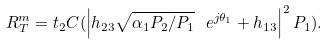Convert formula to latex. <formula><loc_0><loc_0><loc_500><loc_500>R _ { T } ^ { m } = t _ { 2 } C ( \left | h _ { 2 3 } \sqrt { \alpha _ { 1 } P _ { 2 } / P _ { 1 } } \ e ^ { j \theta _ { 1 } } + h _ { 1 3 } \right | ^ { 2 } P _ { 1 } ) .</formula> 